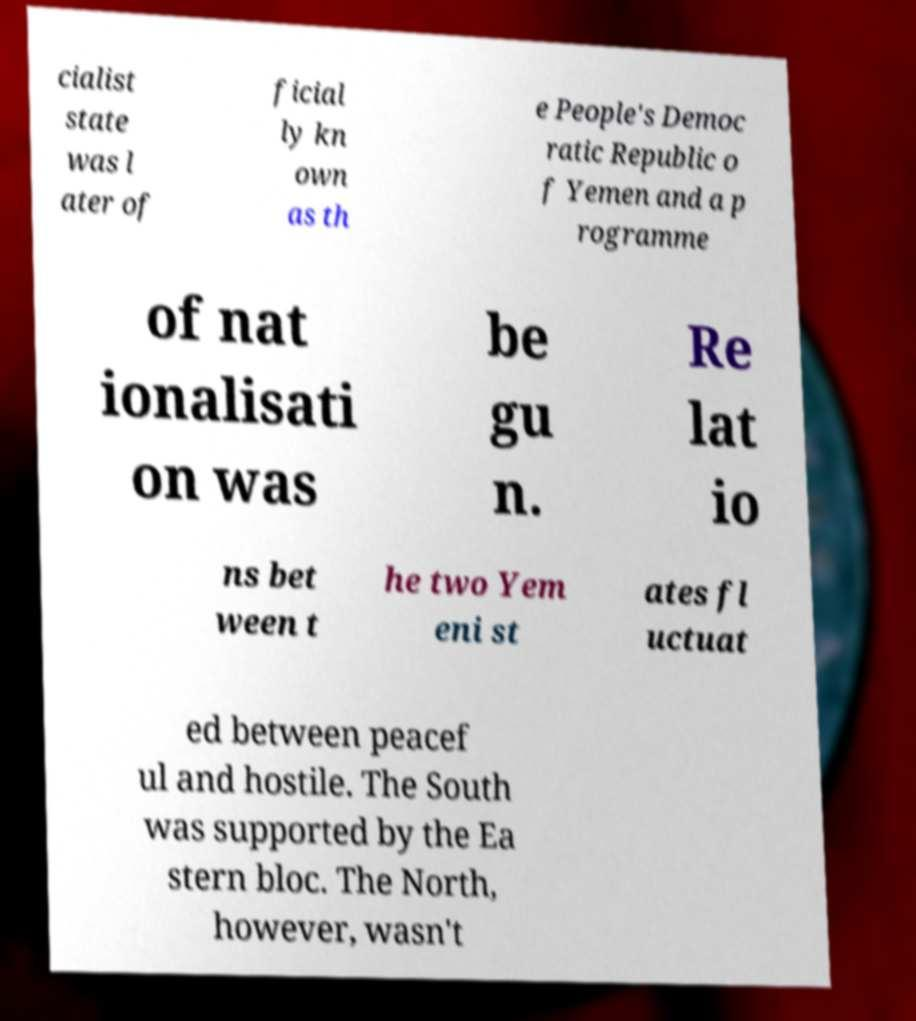For documentation purposes, I need the text within this image transcribed. Could you provide that? cialist state was l ater of ficial ly kn own as th e People's Democ ratic Republic o f Yemen and a p rogramme of nat ionalisati on was be gu n. Re lat io ns bet ween t he two Yem eni st ates fl uctuat ed between peacef ul and hostile. The South was supported by the Ea stern bloc. The North, however, wasn't 